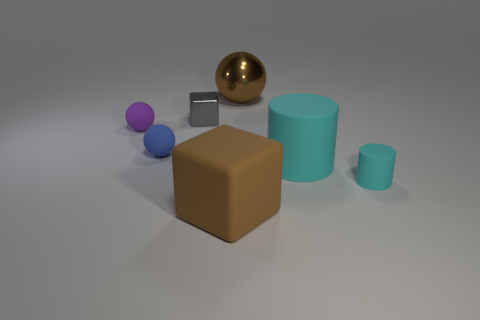Subtract all cyan cubes. Subtract all purple cylinders. How many cubes are left? 2 Add 1 tiny gray metal cubes. How many objects exist? 8 Subtract all spheres. How many objects are left? 4 Add 7 green metal cylinders. How many green metal cylinders exist? 7 Subtract 0 blue cubes. How many objects are left? 7 Subtract all tiny purple rubber cubes. Subtract all tiny cyan cylinders. How many objects are left? 6 Add 7 small matte cylinders. How many small matte cylinders are left? 8 